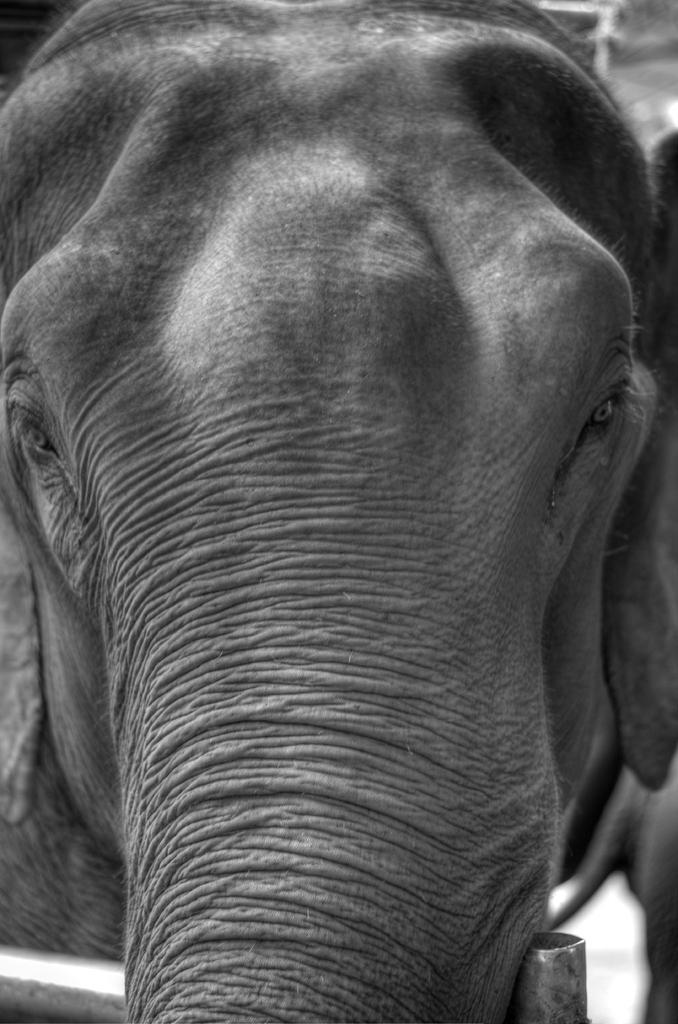Describe this image in one or two sentences. In this picture there is a close view of the elephant trunk. 